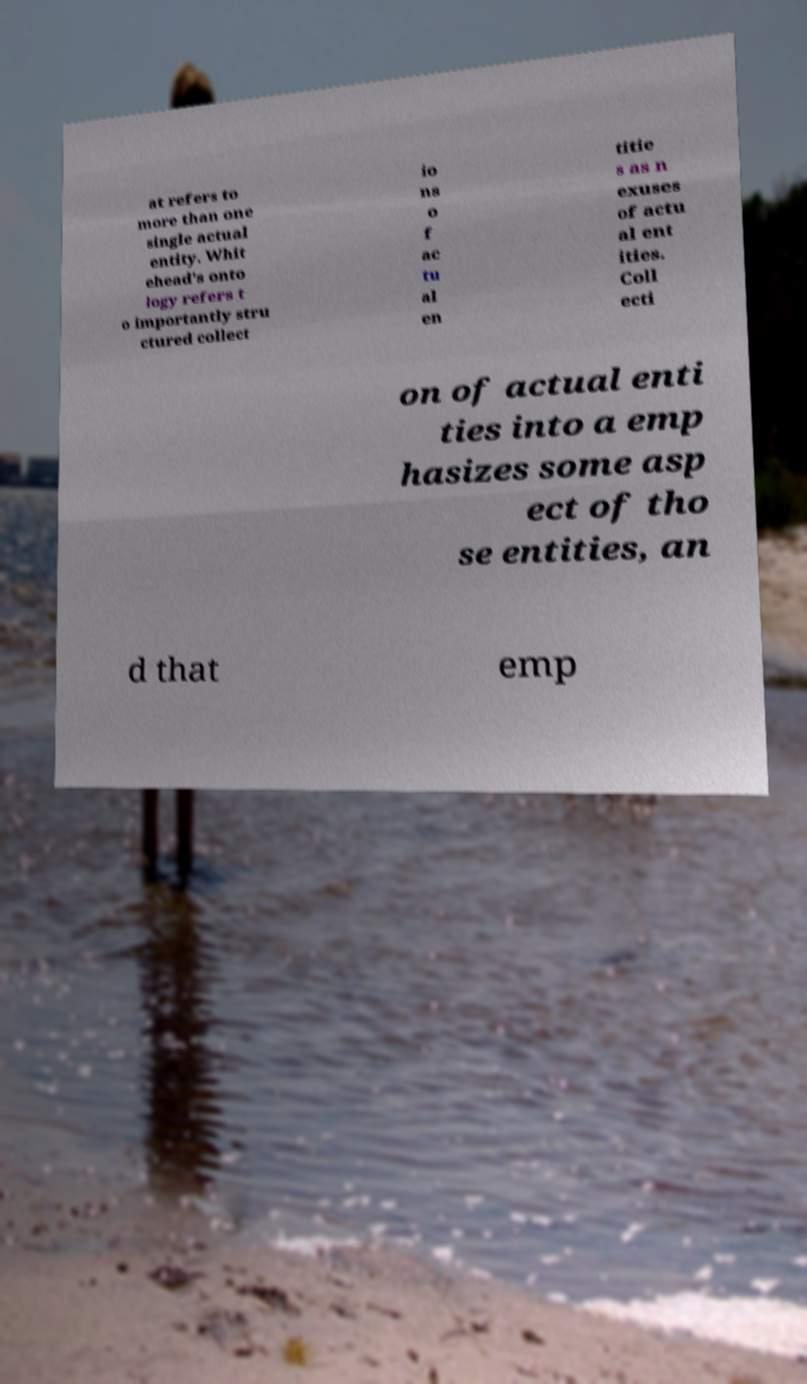Please identify and transcribe the text found in this image. at refers to more than one single actual entity. Whit ehead's onto logy refers t o importantly stru ctured collect io ns o f ac tu al en titie s as n exuses of actu al ent ities. Coll ecti on of actual enti ties into a emp hasizes some asp ect of tho se entities, an d that emp 